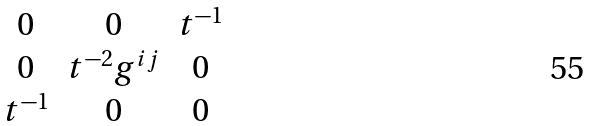Convert formula to latex. <formula><loc_0><loc_0><loc_500><loc_500>\begin{matrix} 0 & 0 & t ^ { - 1 } \\ 0 & t ^ { - 2 } g ^ { i j } & 0 \\ t ^ { - 1 } & 0 & 0 \end{matrix}</formula> 